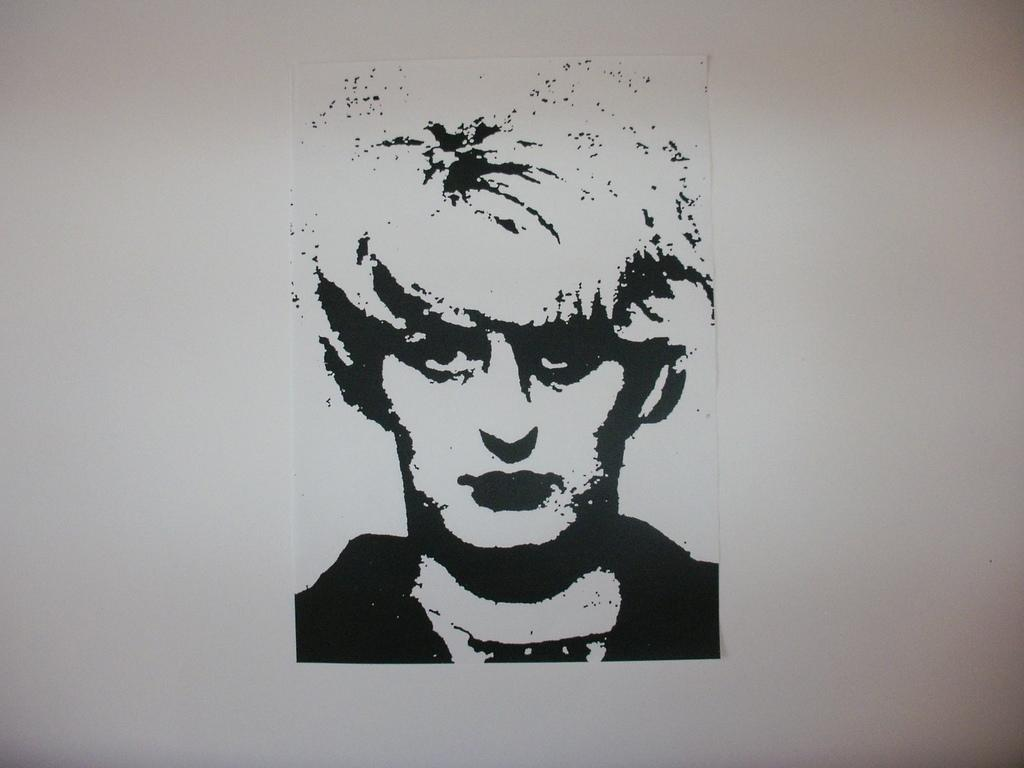What is present on the wall in the image? There is a painting of a person on paper on the wall. What is the subject of the painting? The painting is of a person. How is the painting displayed on the wall? The paper with the painting is on the wall. What type of operation is being performed on the person in the painting? There is no operation being performed on the person in the painting, as it is a static image of a person. 